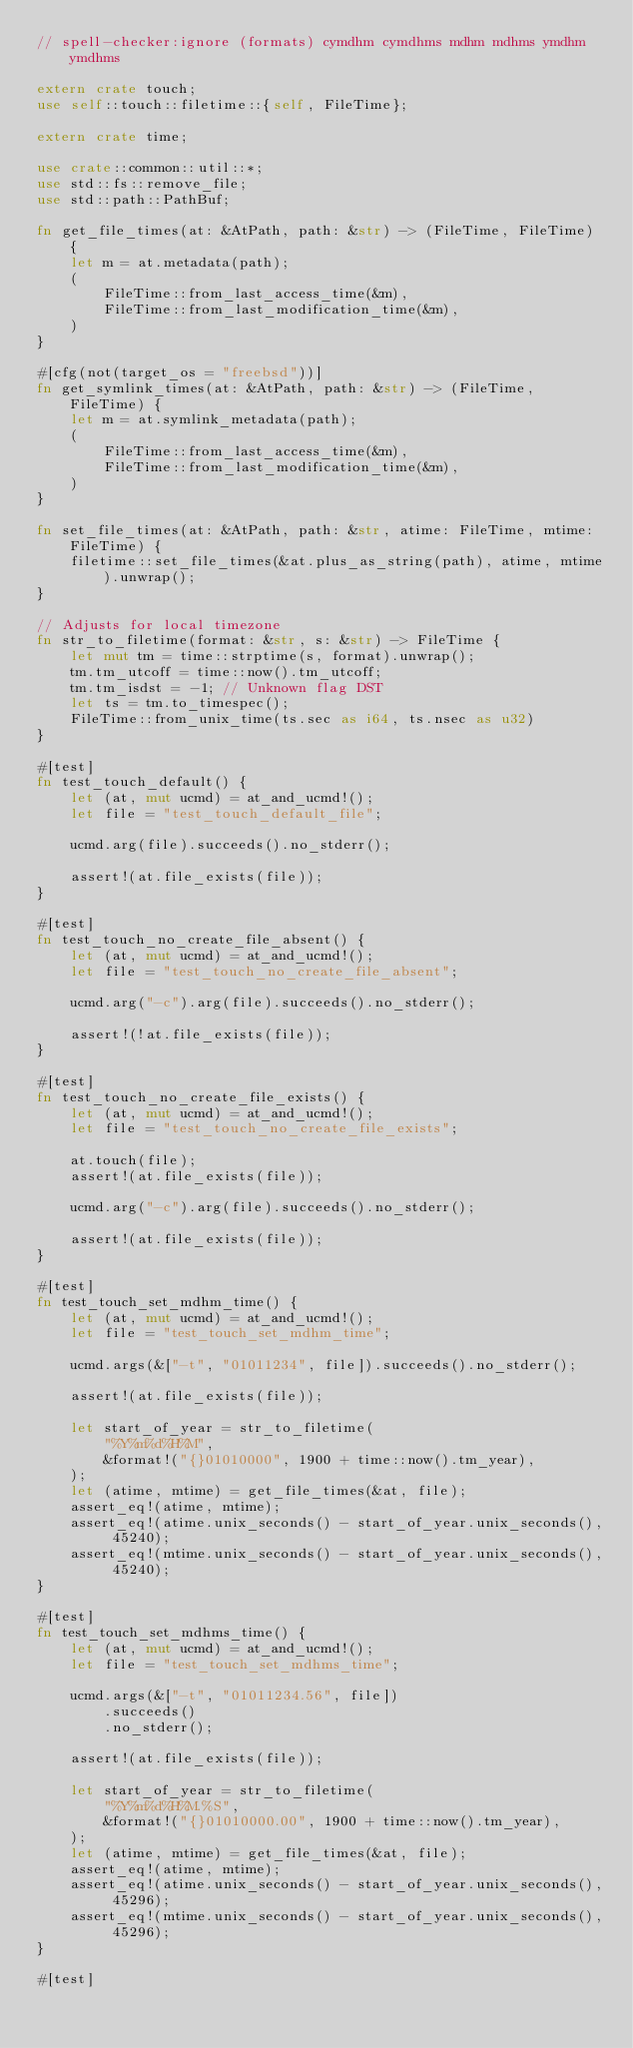<code> <loc_0><loc_0><loc_500><loc_500><_Rust_>// spell-checker:ignore (formats) cymdhm cymdhms mdhm mdhms ymdhm ymdhms

extern crate touch;
use self::touch::filetime::{self, FileTime};

extern crate time;

use crate::common::util::*;
use std::fs::remove_file;
use std::path::PathBuf;

fn get_file_times(at: &AtPath, path: &str) -> (FileTime, FileTime) {
    let m = at.metadata(path);
    (
        FileTime::from_last_access_time(&m),
        FileTime::from_last_modification_time(&m),
    )
}

#[cfg(not(target_os = "freebsd"))]
fn get_symlink_times(at: &AtPath, path: &str) -> (FileTime, FileTime) {
    let m = at.symlink_metadata(path);
    (
        FileTime::from_last_access_time(&m),
        FileTime::from_last_modification_time(&m),
    )
}

fn set_file_times(at: &AtPath, path: &str, atime: FileTime, mtime: FileTime) {
    filetime::set_file_times(&at.plus_as_string(path), atime, mtime).unwrap();
}

// Adjusts for local timezone
fn str_to_filetime(format: &str, s: &str) -> FileTime {
    let mut tm = time::strptime(s, format).unwrap();
    tm.tm_utcoff = time::now().tm_utcoff;
    tm.tm_isdst = -1; // Unknown flag DST
    let ts = tm.to_timespec();
    FileTime::from_unix_time(ts.sec as i64, ts.nsec as u32)
}

#[test]
fn test_touch_default() {
    let (at, mut ucmd) = at_and_ucmd!();
    let file = "test_touch_default_file";

    ucmd.arg(file).succeeds().no_stderr();

    assert!(at.file_exists(file));
}

#[test]
fn test_touch_no_create_file_absent() {
    let (at, mut ucmd) = at_and_ucmd!();
    let file = "test_touch_no_create_file_absent";

    ucmd.arg("-c").arg(file).succeeds().no_stderr();

    assert!(!at.file_exists(file));
}

#[test]
fn test_touch_no_create_file_exists() {
    let (at, mut ucmd) = at_and_ucmd!();
    let file = "test_touch_no_create_file_exists";

    at.touch(file);
    assert!(at.file_exists(file));

    ucmd.arg("-c").arg(file).succeeds().no_stderr();

    assert!(at.file_exists(file));
}

#[test]
fn test_touch_set_mdhm_time() {
    let (at, mut ucmd) = at_and_ucmd!();
    let file = "test_touch_set_mdhm_time";

    ucmd.args(&["-t", "01011234", file]).succeeds().no_stderr();

    assert!(at.file_exists(file));

    let start_of_year = str_to_filetime(
        "%Y%m%d%H%M",
        &format!("{}01010000", 1900 + time::now().tm_year),
    );
    let (atime, mtime) = get_file_times(&at, file);
    assert_eq!(atime, mtime);
    assert_eq!(atime.unix_seconds() - start_of_year.unix_seconds(), 45240);
    assert_eq!(mtime.unix_seconds() - start_of_year.unix_seconds(), 45240);
}

#[test]
fn test_touch_set_mdhms_time() {
    let (at, mut ucmd) = at_and_ucmd!();
    let file = "test_touch_set_mdhms_time";

    ucmd.args(&["-t", "01011234.56", file])
        .succeeds()
        .no_stderr();

    assert!(at.file_exists(file));

    let start_of_year = str_to_filetime(
        "%Y%m%d%H%M.%S",
        &format!("{}01010000.00", 1900 + time::now().tm_year),
    );
    let (atime, mtime) = get_file_times(&at, file);
    assert_eq!(atime, mtime);
    assert_eq!(atime.unix_seconds() - start_of_year.unix_seconds(), 45296);
    assert_eq!(mtime.unix_seconds() - start_of_year.unix_seconds(), 45296);
}

#[test]</code> 